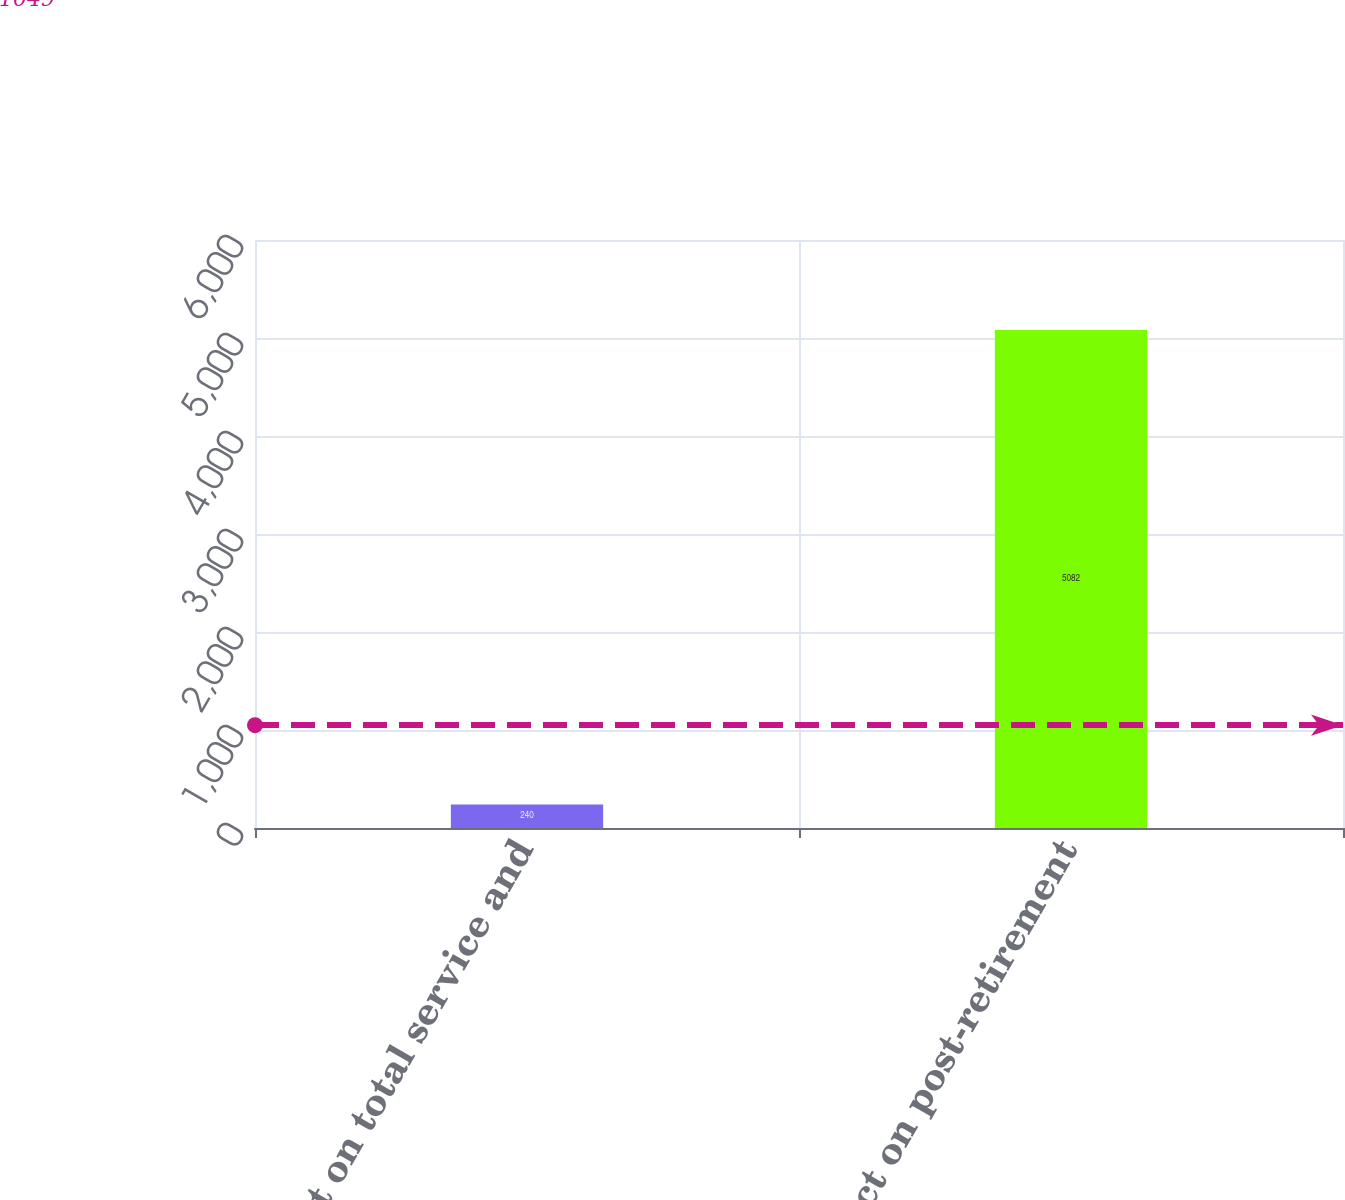Convert chart. <chart><loc_0><loc_0><loc_500><loc_500><bar_chart><fcel>Effect on total service and<fcel>Effect on post-retirement<nl><fcel>240<fcel>5082<nl></chart> 